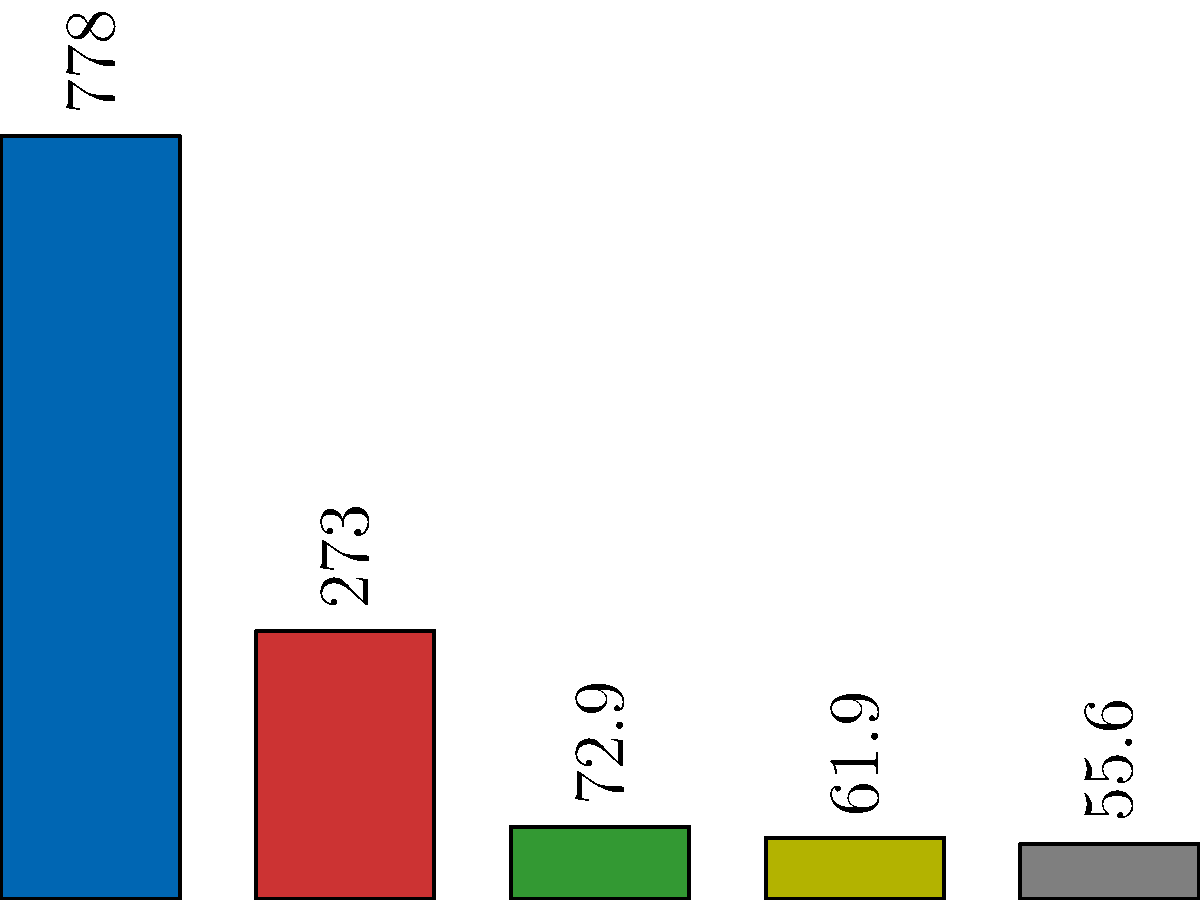As a freelance writer focusing on global conflicts, you come across this bar graph showing military expenditures of different countries. Which country has the second-highest military expenditure, and what is the approximate difference between its spending and that of the United States? To answer this question, we need to follow these steps:

1. Identify the countries represented in the graph:
   The graph shows military expenditures for USA, China, Russia, UK, and Germany.

2. Determine the second-highest military expenditure:
   - USA has the highest at $778 billion
   - China has the second-highest at $273 billion

3. Calculate the difference between USA and China's expenditures:
   $778 billion - $273 billion = $505 billion

Therefore, China has the second-highest military expenditure, and the difference between its spending and that of the United States is approximately $505 billion.

This significant gap in military spending highlights the vast disparity in defense budgets between the world's two largest economies, which is crucial information for understanding global power dynamics and potential areas of conflict.
Answer: China; $505 billion 